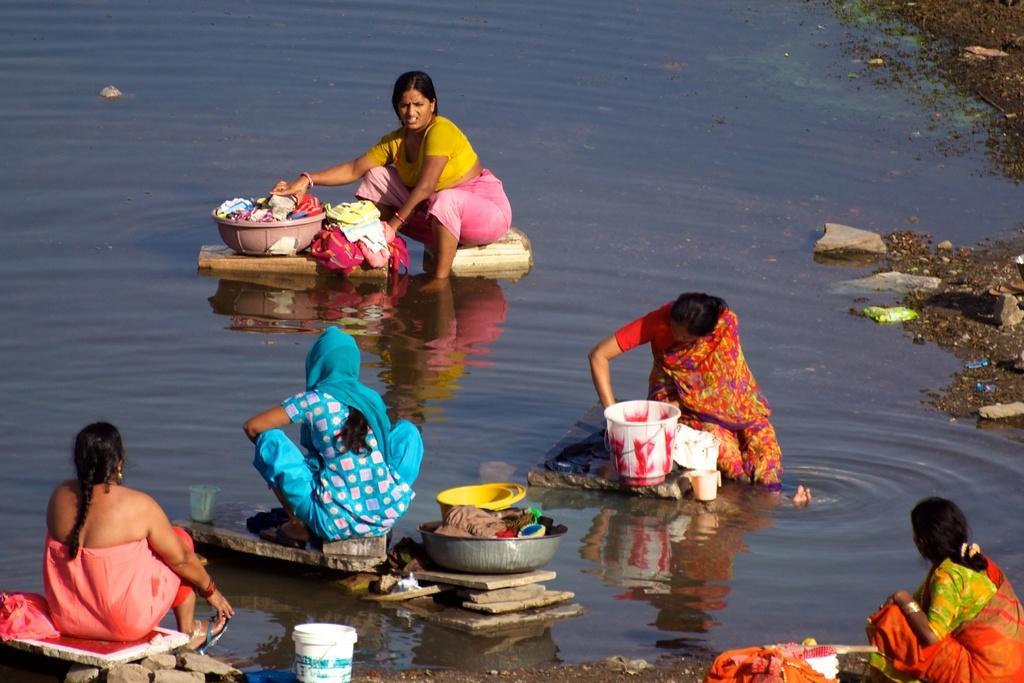Please provide a concise description of this image. In this image, we can see some women washing the clothes, we can see water. 